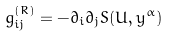<formula> <loc_0><loc_0><loc_500><loc_500>g _ { i j } ^ { ( R ) } = - \partial _ { i } \partial _ { j } S ( U , y ^ { \alpha } )</formula> 